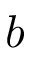Convert formula to latex. <formula><loc_0><loc_0><loc_500><loc_500>b</formula> 